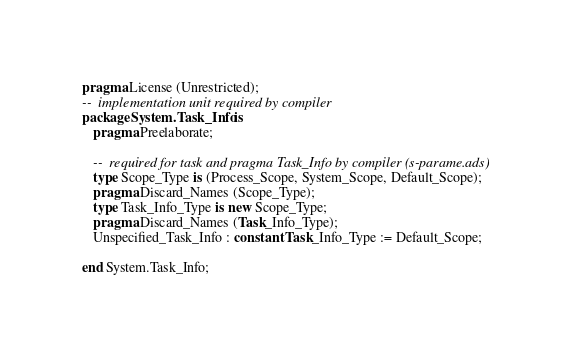Convert code to text. <code><loc_0><loc_0><loc_500><loc_500><_Ada_>pragma License (Unrestricted);
--  implementation unit required by compiler
package System.Task_Info is
   pragma Preelaborate;

   --  required for task and pragma Task_Info by compiler (s-parame.ads)
   type Scope_Type is (Process_Scope, System_Scope, Default_Scope);
   pragma Discard_Names (Scope_Type);
   type Task_Info_Type is new Scope_Type;
   pragma Discard_Names (Task_Info_Type);
   Unspecified_Task_Info : constant Task_Info_Type := Default_Scope;

end System.Task_Info;
</code> 